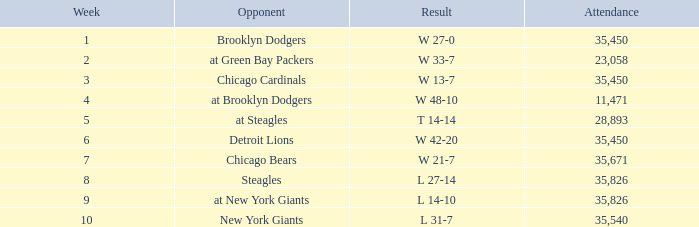What is the lowest attendance that has a week less than 4, and w 13-7 as the result? 35450.0. 